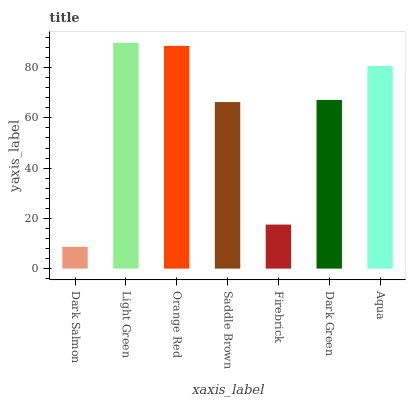Is Dark Salmon the minimum?
Answer yes or no. Yes. Is Light Green the maximum?
Answer yes or no. Yes. Is Orange Red the minimum?
Answer yes or no. No. Is Orange Red the maximum?
Answer yes or no. No. Is Light Green greater than Orange Red?
Answer yes or no. Yes. Is Orange Red less than Light Green?
Answer yes or no. Yes. Is Orange Red greater than Light Green?
Answer yes or no. No. Is Light Green less than Orange Red?
Answer yes or no. No. Is Dark Green the high median?
Answer yes or no. Yes. Is Dark Green the low median?
Answer yes or no. Yes. Is Firebrick the high median?
Answer yes or no. No. Is Light Green the low median?
Answer yes or no. No. 